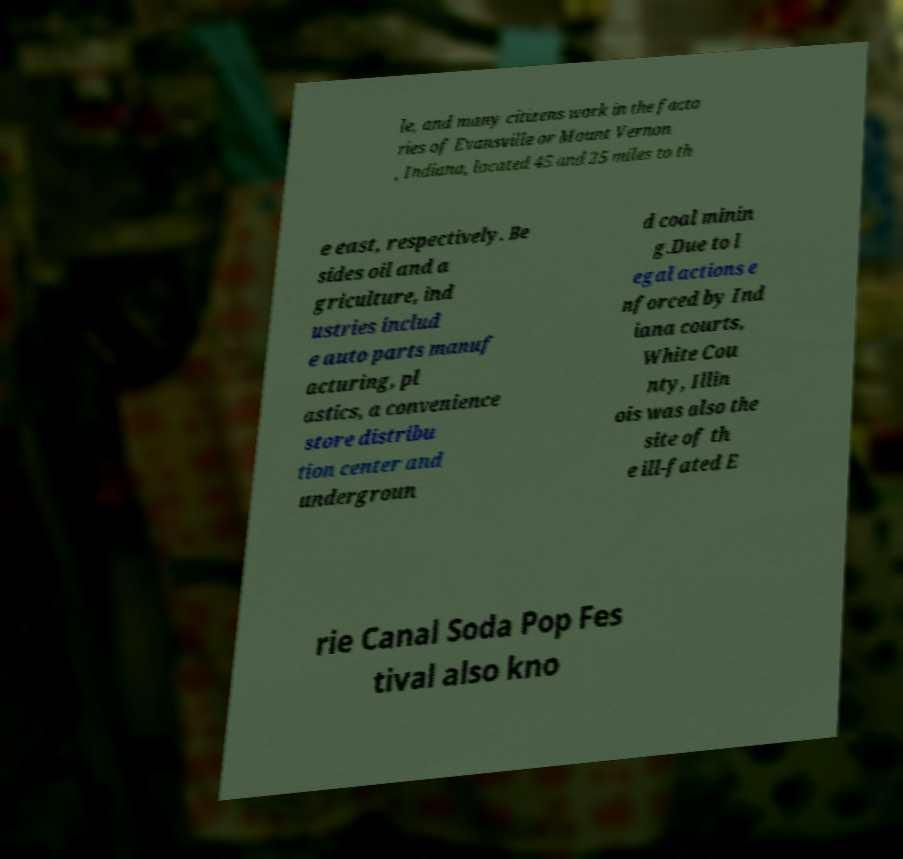There's text embedded in this image that I need extracted. Can you transcribe it verbatim? le, and many citizens work in the facto ries of Evansville or Mount Vernon , Indiana, located 45 and 25 miles to th e east, respectively. Be sides oil and a griculture, ind ustries includ e auto parts manuf acturing, pl astics, a convenience store distribu tion center and undergroun d coal minin g.Due to l egal actions e nforced by Ind iana courts, White Cou nty, Illin ois was also the site of th e ill-fated E rie Canal Soda Pop Fes tival also kno 